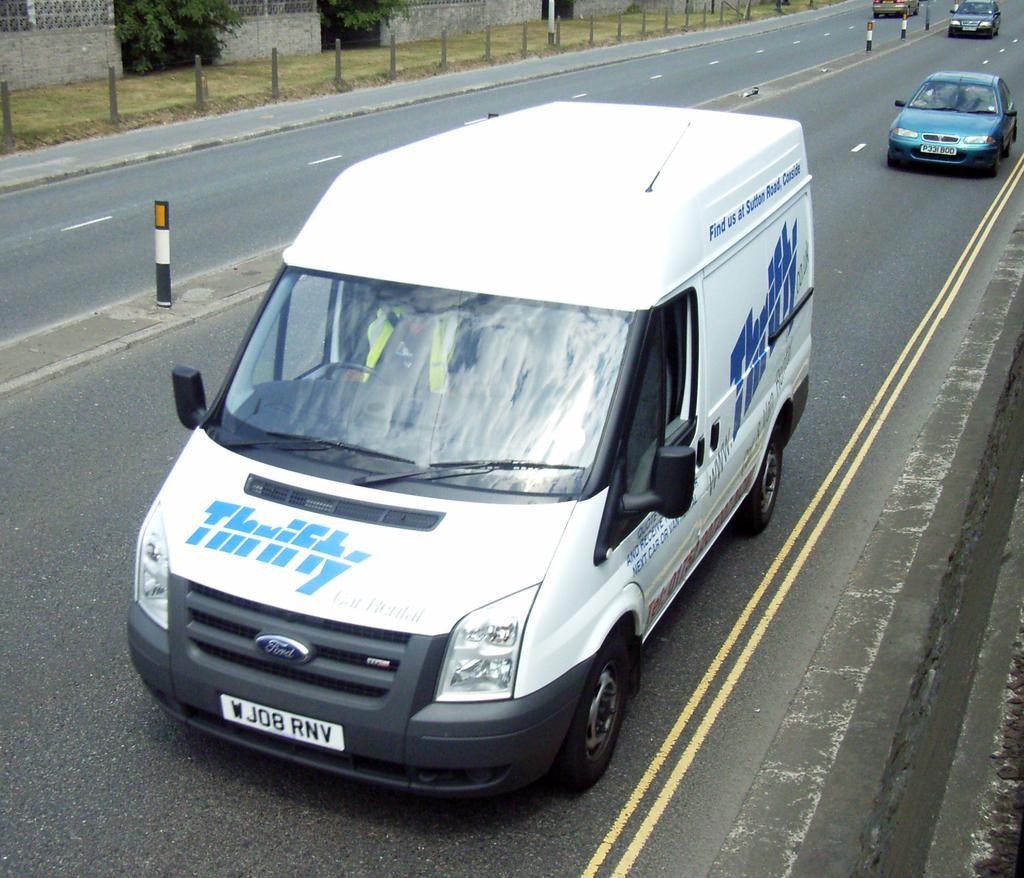Describe this image in one or two sentences. In this image there are different type of vehicles riding on the road, beside that there is a grass on the pavement and compound wall with some plants. 